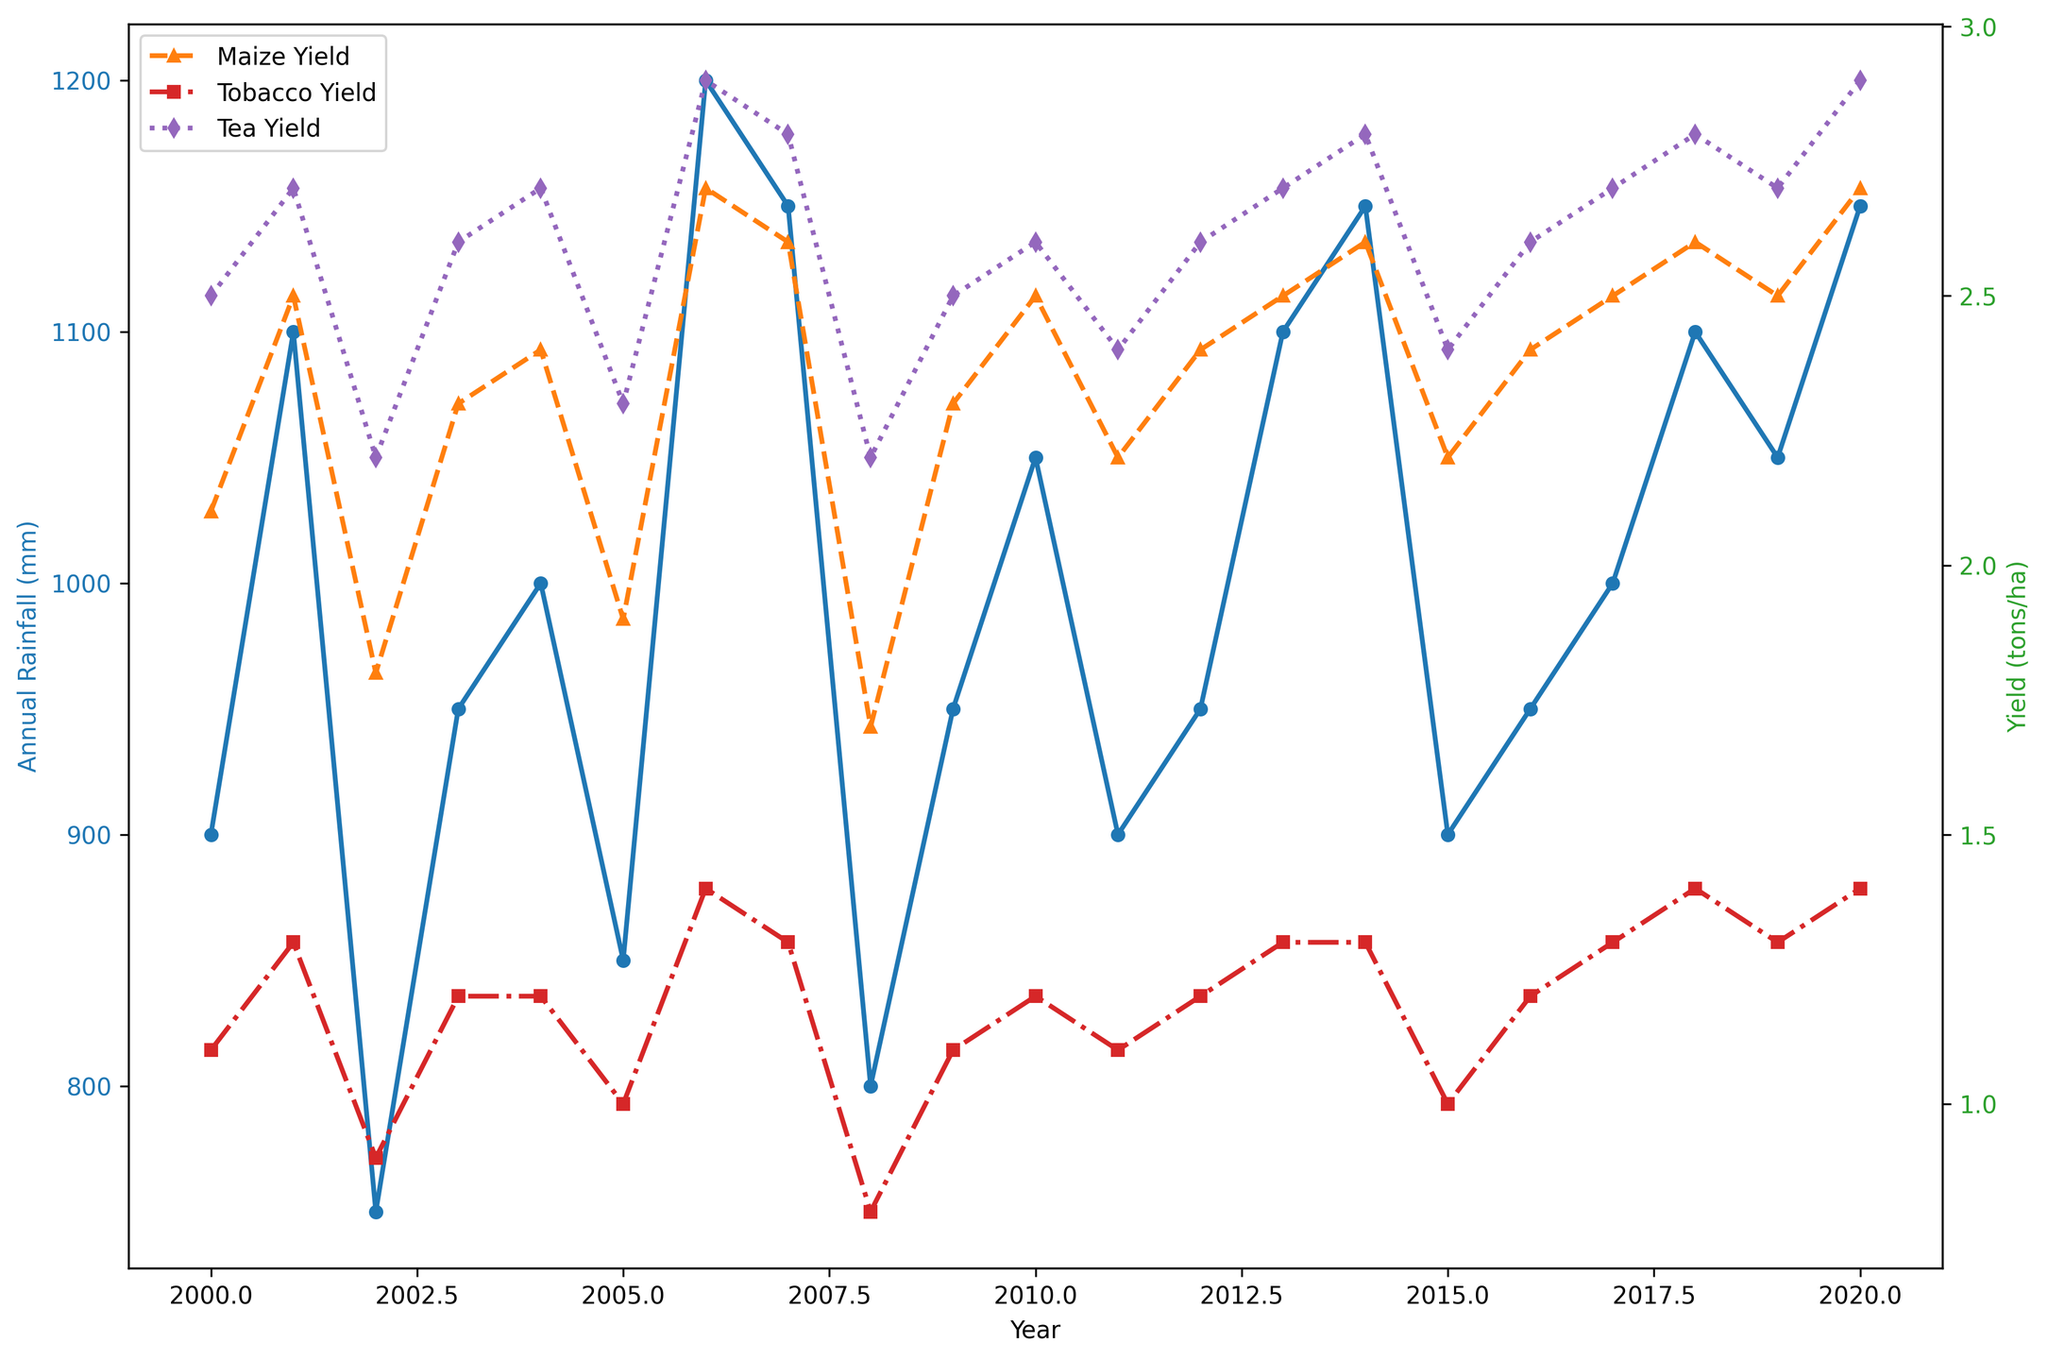How did the annual rainfall trend from 2000 to 2020? To determine the trend, observe the annual rainfall values over the given years. The rainfall values fluctuate, generally showing an increase in certain periods (e.g., between 2001 and 2006, and 2013 and 2020) with fluctuations in other years.
Answer: The annual rainfall fluctuated but showed periods of increasing trends Which year had the highest maize yield, and what was the corresponding annual rainfall? Scan the maize yield values and identify the year with the highest yield. The year 2020 had the highest yield of 2.7 tons/ha. Cross-reference this with the annual rainfall data for 2020 to find it was 1150 mm.
Answer: 2020, 1150 mm During what years did tobacco yields remain constant, and what was the average annual rainfall in those years? Observe the tobacco yield line and notice the years where it remains the same. Tobacco yields were constant at 1.2 tons/ha during 2003-2004, 2009-2010, and 2012. Calculate the average annual rainfall for these years: (950 + 1000 + 950 + 1050 + 950) / 5 = 980 mm.
Answer: 2003-2004, 2009-2010, 2012; 980 mm Which crop yield shows the least variability over the years? Examine the yield lines for each crop to assess their variability visually. Tea yield shows the least fluctuation compared to maize and tobacco yields, remaining nearly consistent over the years.
Answer: Tea What year had an unusually low annual rainfall, and how did it impact maize yield? Identify the year with significantly lower rainfall by comparing the annual rainfall values. The year 2002 had the lowest annual rainfall of 750 mm. Compare this year’s maize yield to others and observe it was one of the lower yields at 1.8 tons/ha.
Answer: 2002, decreased maize yield (1.8 tons/ha) Is there a positive correlation between annual rainfall and maize yield? By visually comparing the trends of rainfall and maize yield data, identify if higher rainfall corresponds with higher yields. Look for general trends, such as higher rainfall years like 2006 and 2020 coinciding with higher maize yields.
Answer: Yes What's the visual difference between the line representing annual rainfall and the lines representing crop yields? Describe the visual attributes of the lines: The annual rainfall line is colored blue with circles, while the crop yield lines have different marker shapes and colors (e.g., orange with triangles for maize). The rainfall line uses a solid line while the yields have different dashed styles.
Answer: Different colors and markers In which year did all crop yields (maize, tobacco, tea) decline together, and what was the annual rainfall that year? Detect the year when all three crop yield lines dip simultaneously. The year 2002 shows a decline in all yields. Check the annual rainfall for that year which was 750 mm.
Answer: 2002, 750 mm 